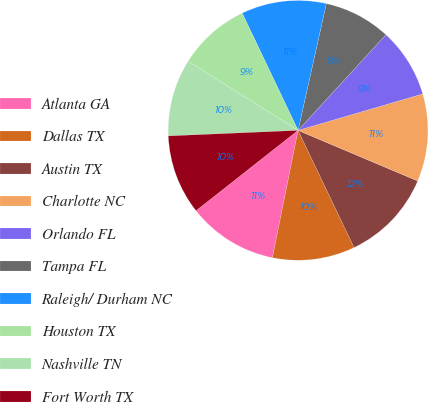<chart> <loc_0><loc_0><loc_500><loc_500><pie_chart><fcel>Atlanta GA<fcel>Dallas TX<fcel>Austin TX<fcel>Charlotte NC<fcel>Orlando FL<fcel>Tampa FL<fcel>Raleigh/ Durham NC<fcel>Houston TX<fcel>Nashville TN<fcel>Fort Worth TX<nl><fcel>11.22%<fcel>10.26%<fcel>11.54%<fcel>10.9%<fcel>8.65%<fcel>8.33%<fcel>10.58%<fcel>8.98%<fcel>9.62%<fcel>9.94%<nl></chart> 